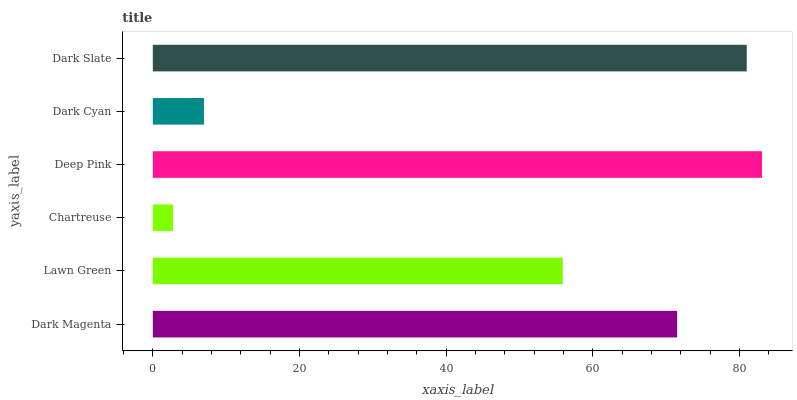Is Chartreuse the minimum?
Answer yes or no. Yes. Is Deep Pink the maximum?
Answer yes or no. Yes. Is Lawn Green the minimum?
Answer yes or no. No. Is Lawn Green the maximum?
Answer yes or no. No. Is Dark Magenta greater than Lawn Green?
Answer yes or no. Yes. Is Lawn Green less than Dark Magenta?
Answer yes or no. Yes. Is Lawn Green greater than Dark Magenta?
Answer yes or no. No. Is Dark Magenta less than Lawn Green?
Answer yes or no. No. Is Dark Magenta the high median?
Answer yes or no. Yes. Is Lawn Green the low median?
Answer yes or no. Yes. Is Chartreuse the high median?
Answer yes or no. No. Is Dark Cyan the low median?
Answer yes or no. No. 